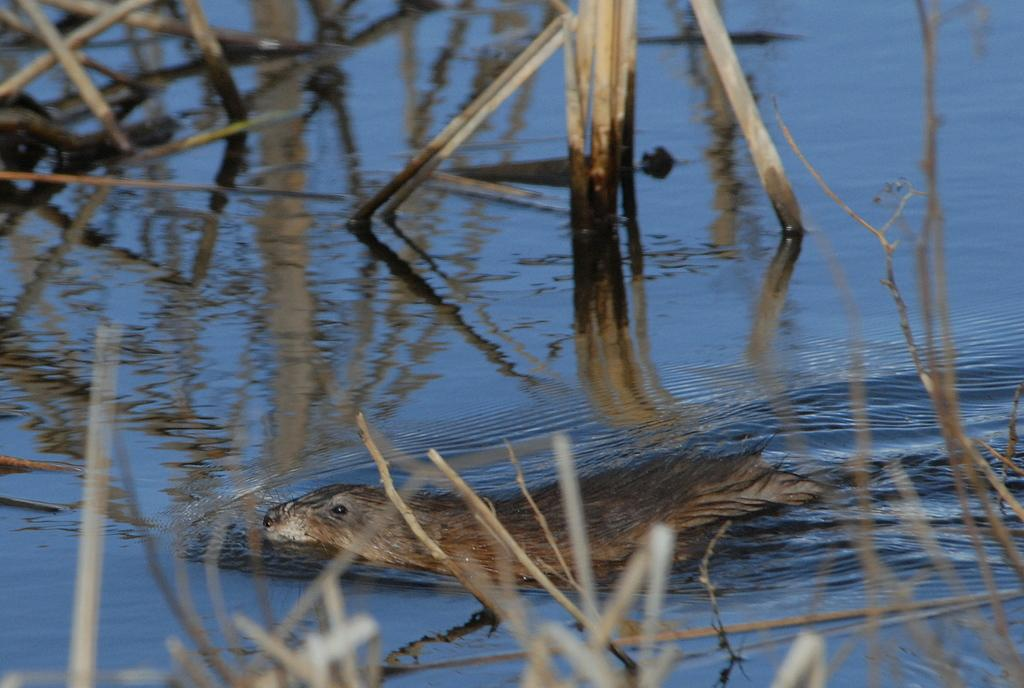What animal is present in the image? There is a sea lion in the image. What is the sea lion doing in the image? The sea lion is swimming in the water. What else can be seen in the water besides the sea lion? There are wooden sticks in the water. What can be seen in the image besides the water? There are plants visible in the image. What type of letters can be seen floating in the water with the sea lion? There are no letters present in the image; it only features a sea lion swimming in the water and wooden sticks. 